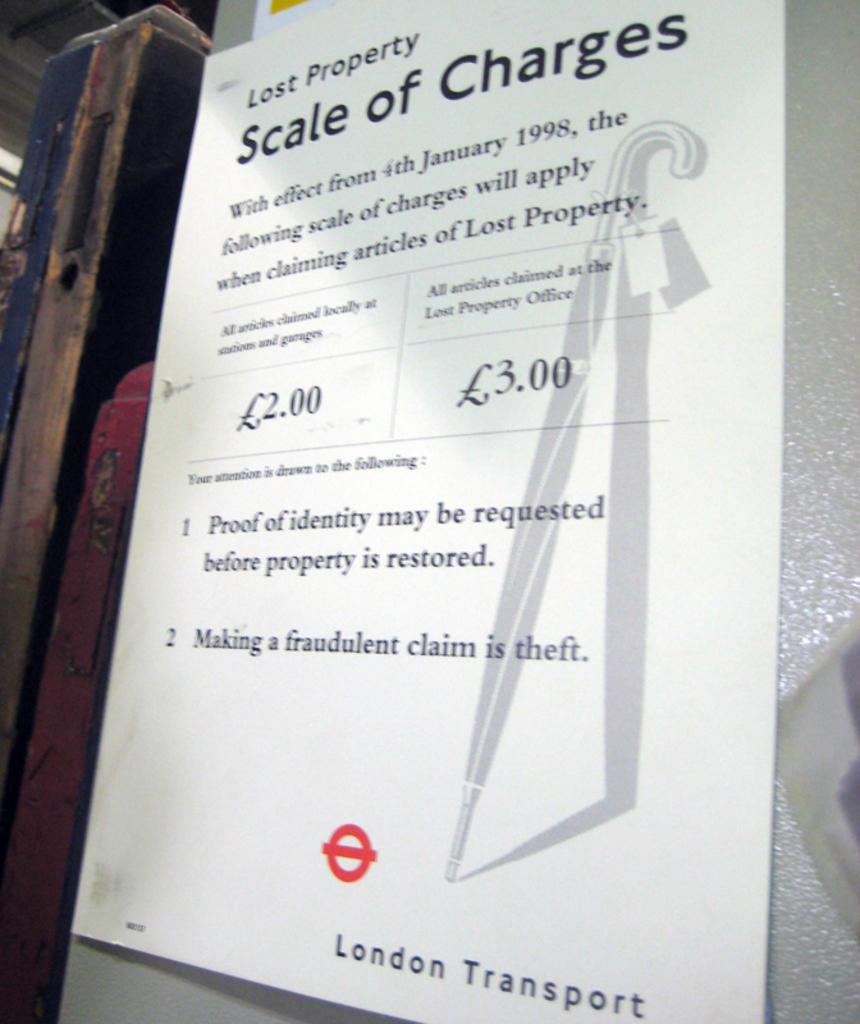<image>
Summarize the visual content of the image. A scale of charges when claiming lost property from the London Transport office. 